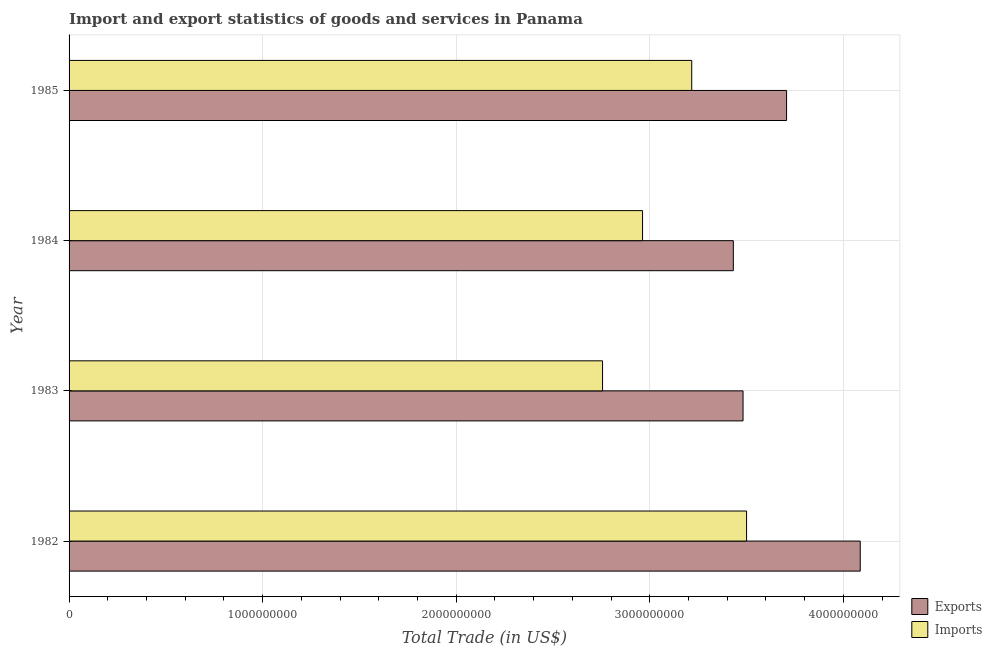Are the number of bars per tick equal to the number of legend labels?
Your answer should be compact. Yes. Are the number of bars on each tick of the Y-axis equal?
Provide a succinct answer. Yes. How many bars are there on the 3rd tick from the top?
Provide a short and direct response. 2. How many bars are there on the 4th tick from the bottom?
Provide a short and direct response. 2. In how many cases, is the number of bars for a given year not equal to the number of legend labels?
Your answer should be compact. 0. What is the export of goods and services in 1984?
Give a very brief answer. 3.43e+09. Across all years, what is the maximum imports of goods and services?
Your answer should be very brief. 3.50e+09. Across all years, what is the minimum imports of goods and services?
Offer a very short reply. 2.76e+09. What is the total imports of goods and services in the graph?
Offer a terse response. 1.24e+1. What is the difference between the export of goods and services in 1983 and that in 1984?
Offer a very short reply. 5.02e+07. What is the difference between the imports of goods and services in 1983 and the export of goods and services in 1982?
Give a very brief answer. -1.33e+09. What is the average imports of goods and services per year?
Your answer should be compact. 3.11e+09. In the year 1984, what is the difference between the export of goods and services and imports of goods and services?
Provide a short and direct response. 4.69e+08. In how many years, is the imports of goods and services greater than 3200000000 US$?
Offer a terse response. 2. What is the ratio of the imports of goods and services in 1983 to that in 1985?
Your response must be concise. 0.86. Is the imports of goods and services in 1984 less than that in 1985?
Offer a very short reply. Yes. Is the difference between the imports of goods and services in 1982 and 1983 greater than the difference between the export of goods and services in 1982 and 1983?
Keep it short and to the point. Yes. What is the difference between the highest and the second highest imports of goods and services?
Provide a succinct answer. 2.83e+08. What is the difference between the highest and the lowest imports of goods and services?
Your response must be concise. 7.44e+08. What does the 1st bar from the top in 1983 represents?
Your answer should be very brief. Imports. What does the 1st bar from the bottom in 1984 represents?
Give a very brief answer. Exports. How many years are there in the graph?
Your response must be concise. 4. What is the difference between two consecutive major ticks on the X-axis?
Offer a very short reply. 1.00e+09. Are the values on the major ticks of X-axis written in scientific E-notation?
Make the answer very short. No. Does the graph contain any zero values?
Your response must be concise. No. Does the graph contain grids?
Your answer should be very brief. Yes. Where does the legend appear in the graph?
Provide a succinct answer. Bottom right. How are the legend labels stacked?
Make the answer very short. Vertical. What is the title of the graph?
Offer a terse response. Import and export statistics of goods and services in Panama. What is the label or title of the X-axis?
Offer a terse response. Total Trade (in US$). What is the label or title of the Y-axis?
Make the answer very short. Year. What is the Total Trade (in US$) of Exports in 1982?
Keep it short and to the point. 4.09e+09. What is the Total Trade (in US$) in Imports in 1982?
Your response must be concise. 3.50e+09. What is the Total Trade (in US$) in Exports in 1983?
Offer a terse response. 3.48e+09. What is the Total Trade (in US$) of Imports in 1983?
Offer a terse response. 2.76e+09. What is the Total Trade (in US$) in Exports in 1984?
Give a very brief answer. 3.43e+09. What is the Total Trade (in US$) of Imports in 1984?
Keep it short and to the point. 2.96e+09. What is the Total Trade (in US$) in Exports in 1985?
Give a very brief answer. 3.71e+09. What is the Total Trade (in US$) in Imports in 1985?
Make the answer very short. 3.22e+09. Across all years, what is the maximum Total Trade (in US$) of Exports?
Your answer should be very brief. 4.09e+09. Across all years, what is the maximum Total Trade (in US$) in Imports?
Provide a succinct answer. 3.50e+09. Across all years, what is the minimum Total Trade (in US$) in Exports?
Make the answer very short. 3.43e+09. Across all years, what is the minimum Total Trade (in US$) of Imports?
Make the answer very short. 2.76e+09. What is the total Total Trade (in US$) in Exports in the graph?
Provide a succinct answer. 1.47e+1. What is the total Total Trade (in US$) of Imports in the graph?
Provide a short and direct response. 1.24e+1. What is the difference between the Total Trade (in US$) of Exports in 1982 and that in 1983?
Provide a short and direct response. 6.05e+08. What is the difference between the Total Trade (in US$) in Imports in 1982 and that in 1983?
Offer a very short reply. 7.44e+08. What is the difference between the Total Trade (in US$) of Exports in 1982 and that in 1984?
Provide a short and direct response. 6.56e+08. What is the difference between the Total Trade (in US$) in Imports in 1982 and that in 1984?
Offer a very short reply. 5.37e+08. What is the difference between the Total Trade (in US$) of Exports in 1982 and that in 1985?
Offer a terse response. 3.80e+08. What is the difference between the Total Trade (in US$) in Imports in 1982 and that in 1985?
Ensure brevity in your answer.  2.83e+08. What is the difference between the Total Trade (in US$) of Exports in 1983 and that in 1984?
Offer a very short reply. 5.02e+07. What is the difference between the Total Trade (in US$) of Imports in 1983 and that in 1984?
Keep it short and to the point. -2.07e+08. What is the difference between the Total Trade (in US$) in Exports in 1983 and that in 1985?
Give a very brief answer. -2.25e+08. What is the difference between the Total Trade (in US$) of Imports in 1983 and that in 1985?
Keep it short and to the point. -4.61e+08. What is the difference between the Total Trade (in US$) in Exports in 1984 and that in 1985?
Give a very brief answer. -2.75e+08. What is the difference between the Total Trade (in US$) of Imports in 1984 and that in 1985?
Your answer should be compact. -2.54e+08. What is the difference between the Total Trade (in US$) of Exports in 1982 and the Total Trade (in US$) of Imports in 1983?
Ensure brevity in your answer.  1.33e+09. What is the difference between the Total Trade (in US$) in Exports in 1982 and the Total Trade (in US$) in Imports in 1984?
Provide a succinct answer. 1.12e+09. What is the difference between the Total Trade (in US$) in Exports in 1982 and the Total Trade (in US$) in Imports in 1985?
Offer a terse response. 8.70e+08. What is the difference between the Total Trade (in US$) in Exports in 1983 and the Total Trade (in US$) in Imports in 1984?
Your answer should be compact. 5.19e+08. What is the difference between the Total Trade (in US$) in Exports in 1983 and the Total Trade (in US$) in Imports in 1985?
Your answer should be compact. 2.65e+08. What is the difference between the Total Trade (in US$) of Exports in 1984 and the Total Trade (in US$) of Imports in 1985?
Provide a succinct answer. 2.15e+08. What is the average Total Trade (in US$) in Exports per year?
Your response must be concise. 3.68e+09. What is the average Total Trade (in US$) in Imports per year?
Keep it short and to the point. 3.11e+09. In the year 1982, what is the difference between the Total Trade (in US$) of Exports and Total Trade (in US$) of Imports?
Ensure brevity in your answer.  5.87e+08. In the year 1983, what is the difference between the Total Trade (in US$) in Exports and Total Trade (in US$) in Imports?
Offer a very short reply. 7.26e+08. In the year 1984, what is the difference between the Total Trade (in US$) in Exports and Total Trade (in US$) in Imports?
Your answer should be compact. 4.69e+08. In the year 1985, what is the difference between the Total Trade (in US$) of Exports and Total Trade (in US$) of Imports?
Your answer should be very brief. 4.90e+08. What is the ratio of the Total Trade (in US$) of Exports in 1982 to that in 1983?
Your response must be concise. 1.17. What is the ratio of the Total Trade (in US$) in Imports in 1982 to that in 1983?
Give a very brief answer. 1.27. What is the ratio of the Total Trade (in US$) of Exports in 1982 to that in 1984?
Give a very brief answer. 1.19. What is the ratio of the Total Trade (in US$) of Imports in 1982 to that in 1984?
Ensure brevity in your answer.  1.18. What is the ratio of the Total Trade (in US$) of Exports in 1982 to that in 1985?
Offer a terse response. 1.1. What is the ratio of the Total Trade (in US$) of Imports in 1982 to that in 1985?
Your answer should be compact. 1.09. What is the ratio of the Total Trade (in US$) of Exports in 1983 to that in 1984?
Ensure brevity in your answer.  1.01. What is the ratio of the Total Trade (in US$) in Imports in 1983 to that in 1984?
Offer a terse response. 0.93. What is the ratio of the Total Trade (in US$) of Exports in 1983 to that in 1985?
Keep it short and to the point. 0.94. What is the ratio of the Total Trade (in US$) of Imports in 1983 to that in 1985?
Your answer should be very brief. 0.86. What is the ratio of the Total Trade (in US$) of Exports in 1984 to that in 1985?
Offer a very short reply. 0.93. What is the ratio of the Total Trade (in US$) in Imports in 1984 to that in 1985?
Ensure brevity in your answer.  0.92. What is the difference between the highest and the second highest Total Trade (in US$) of Exports?
Ensure brevity in your answer.  3.80e+08. What is the difference between the highest and the second highest Total Trade (in US$) in Imports?
Offer a very short reply. 2.83e+08. What is the difference between the highest and the lowest Total Trade (in US$) of Exports?
Your answer should be compact. 6.56e+08. What is the difference between the highest and the lowest Total Trade (in US$) in Imports?
Your answer should be very brief. 7.44e+08. 